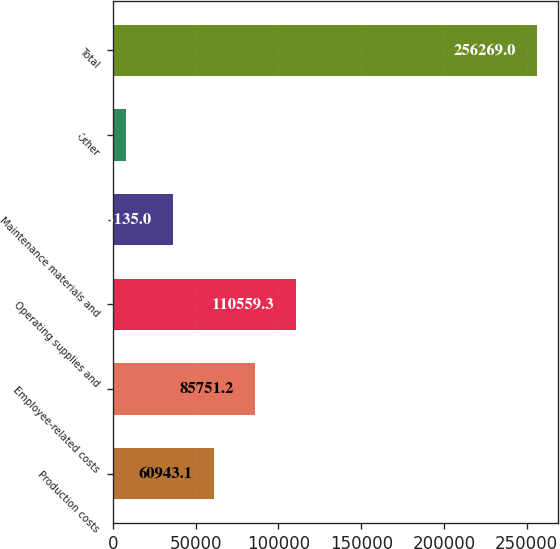<chart> <loc_0><loc_0><loc_500><loc_500><bar_chart><fcel>Production costs<fcel>Employee-related costs<fcel>Operating supplies and<fcel>Maintenance materials and<fcel>Other<fcel>Total<nl><fcel>60943.1<fcel>85751.2<fcel>110559<fcel>36135<fcel>8188<fcel>256269<nl></chart> 